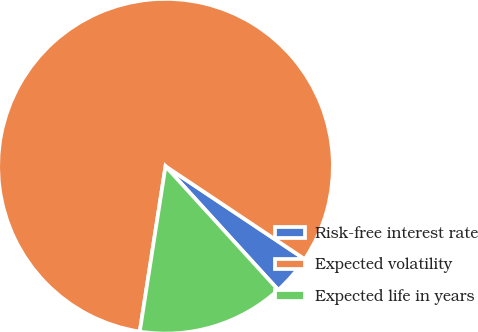Convert chart to OTSL. <chart><loc_0><loc_0><loc_500><loc_500><pie_chart><fcel>Risk-free interest rate<fcel>Expected volatility<fcel>Expected life in years<nl><fcel>3.87%<fcel>81.91%<fcel>14.22%<nl></chart> 